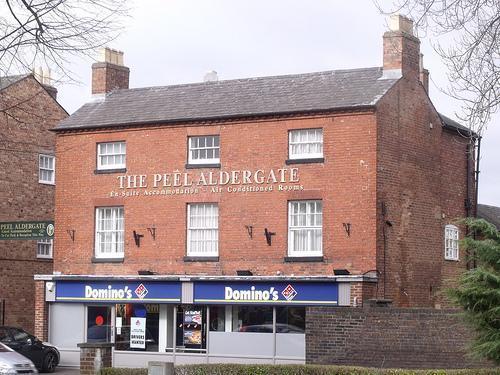How many cars are there?
Give a very brief answer. 2. 